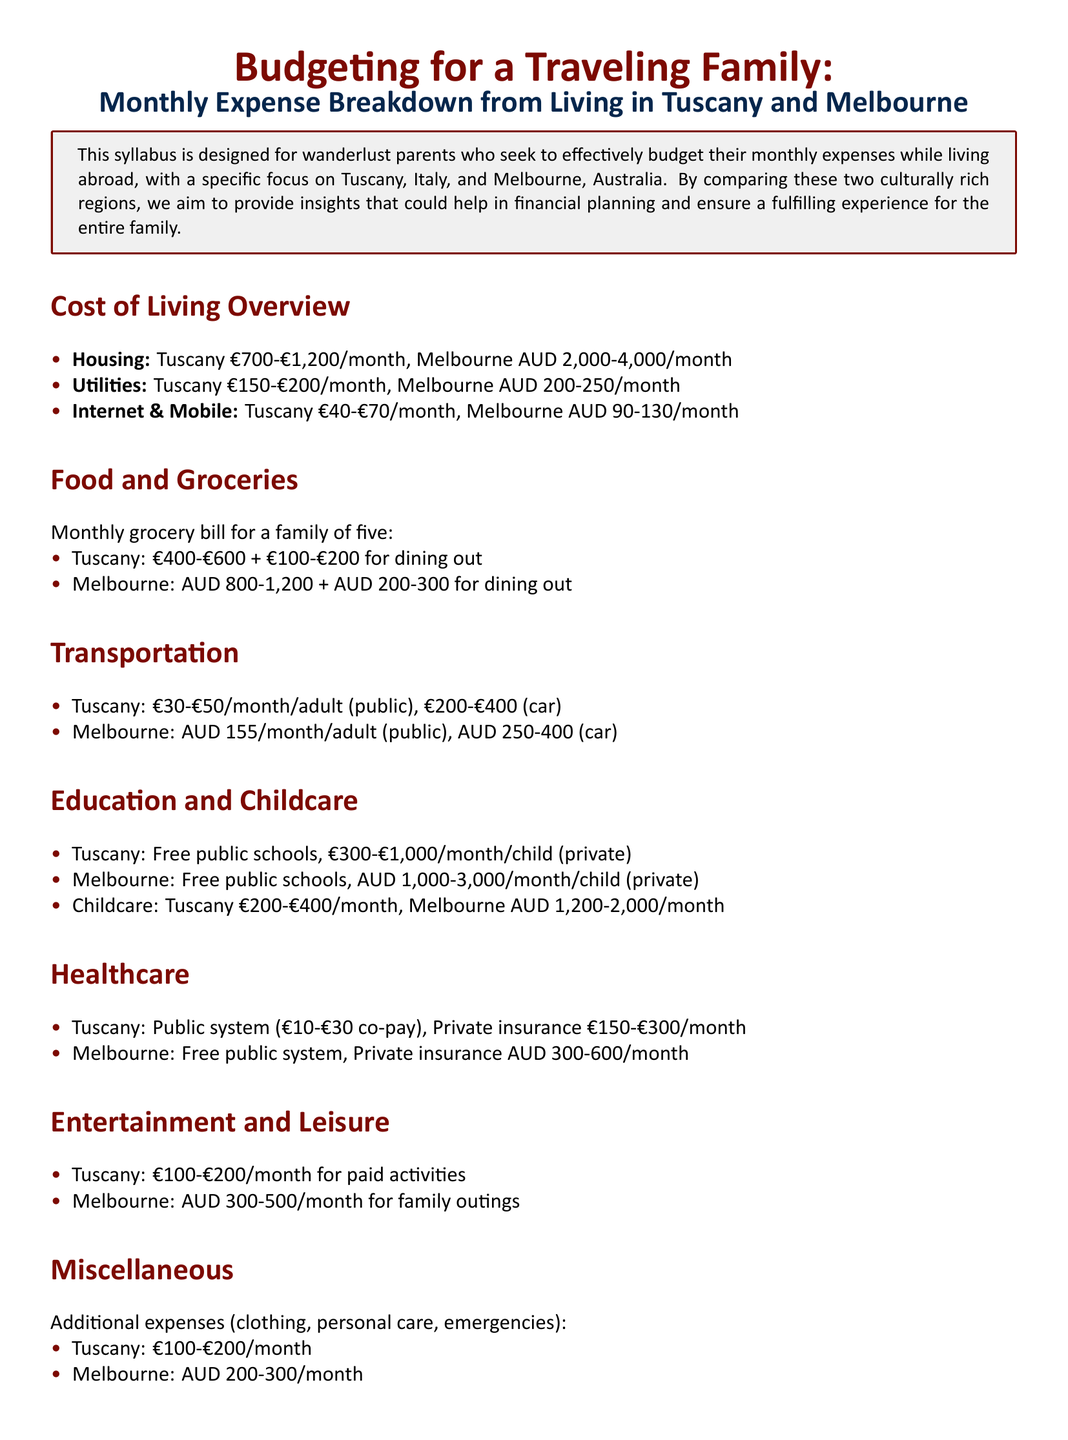What is the housing cost range in Tuscany? The housing cost range in Tuscany is specified in the document as €700-€1,200/month.
Answer: €700-€1,200/month What is the transportation cost per adult in Melbourne? The transportation cost per adult in Melbourne is AUD 155/month for public transportation.
Answer: AUD 155/month What is the average monthly grocery bill for a family of five in Tuscany? The average monthly grocery bill for a family of five in Tuscany is €400-€600 for groceries plus €100-€200 for dining out.
Answer: €400-€600 + €100-€200 What is the childcare cost in Melbourne? The childcare cost in Melbourne is AUD 1,200-2,000/month.
Answer: AUD 1,200-2,000/month Which region has more affordable healthcare? Based on the information given, Tuscany offers lower public healthcare co-payments and private insurance costs compared to Melbourne.
Answer: Tuscany What is the total estimated entertainment expense for a family in Melbourne? The total estimated entertainment expense for a family in Melbourne is AUD 300-500/month for family outings.
Answer: AUD 300-500/month What types of schools offer free education in both Tuscany and Melbourne? The document states that free public schools are available in both Tuscany and Melbourne.
Answer: Free public schools What is the purpose of this syllabus? The purpose of the syllabus is to help wanderlust parents budget their monthly expenses while living abroad.
Answer: Budgeting monthly expenses What additional expenses are mentioned for Tuscany? Additional expenses in Tuscany include clothing, personal care, and emergencies, detailed as €100-€200/month.
Answer: €100-€200/month 